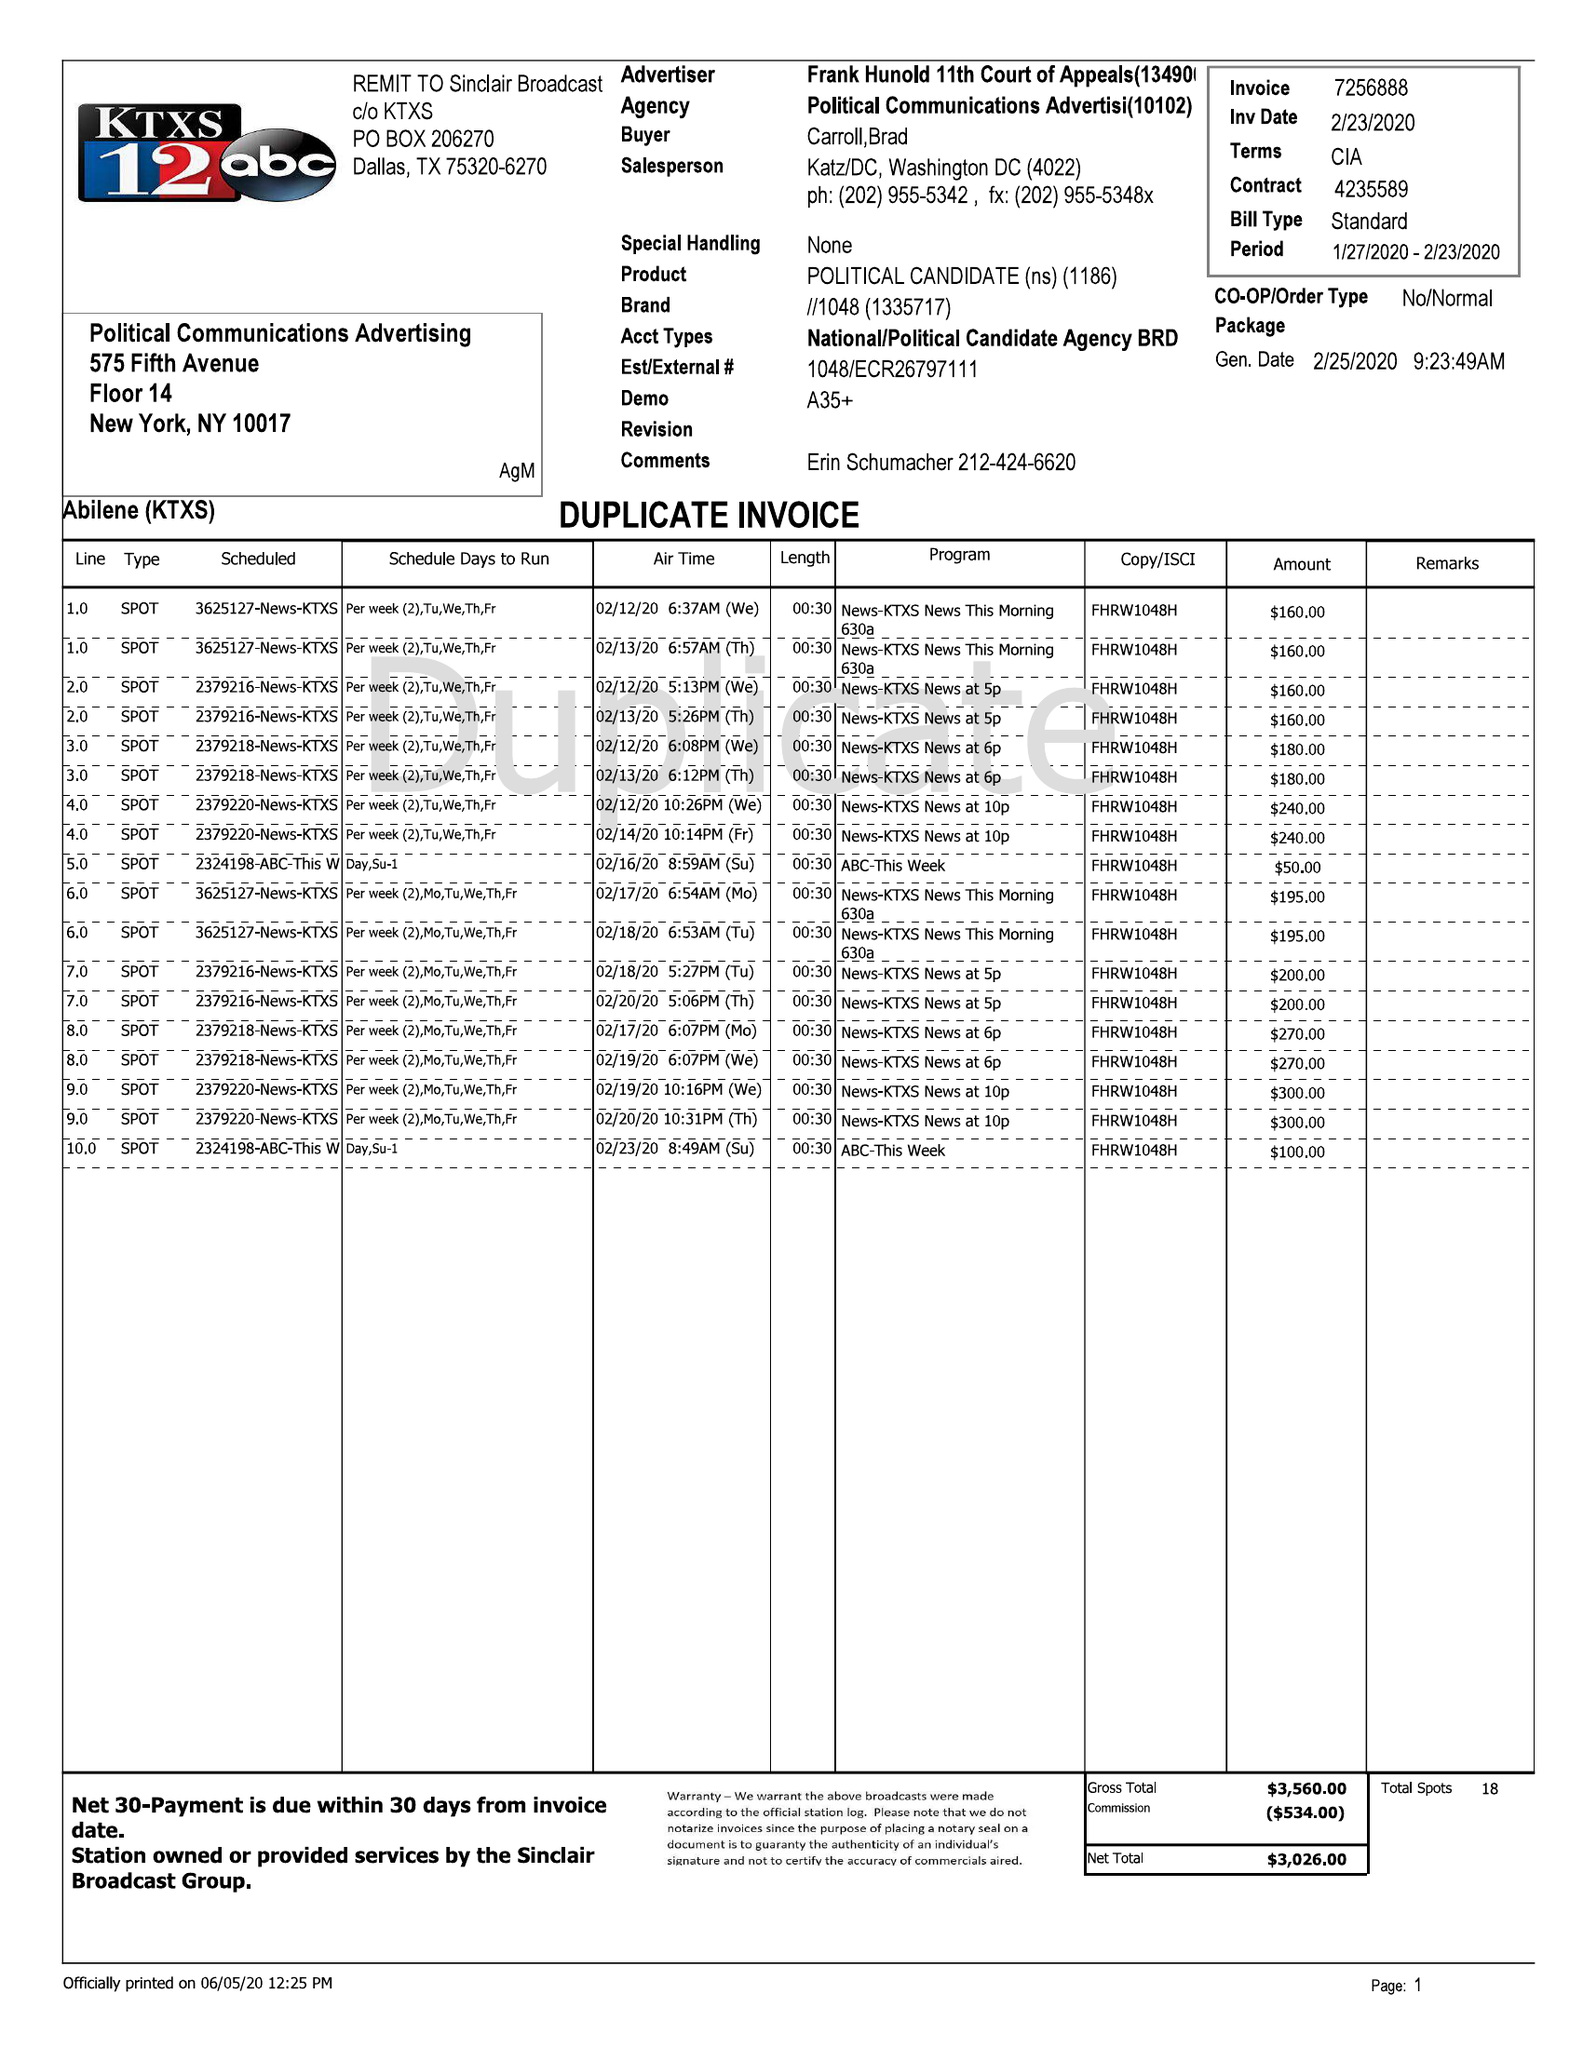What is the value for the advertiser?
Answer the question using a single word or phrase. FRANK HUNOLD 11TH COURT OF APPEALS 